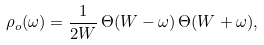Convert formula to latex. <formula><loc_0><loc_0><loc_500><loc_500>\rho _ { o } ( \omega ) = \frac { 1 } { 2 W } \, \Theta ( W - \omega ) \, \Theta ( W + \omega ) ,</formula> 